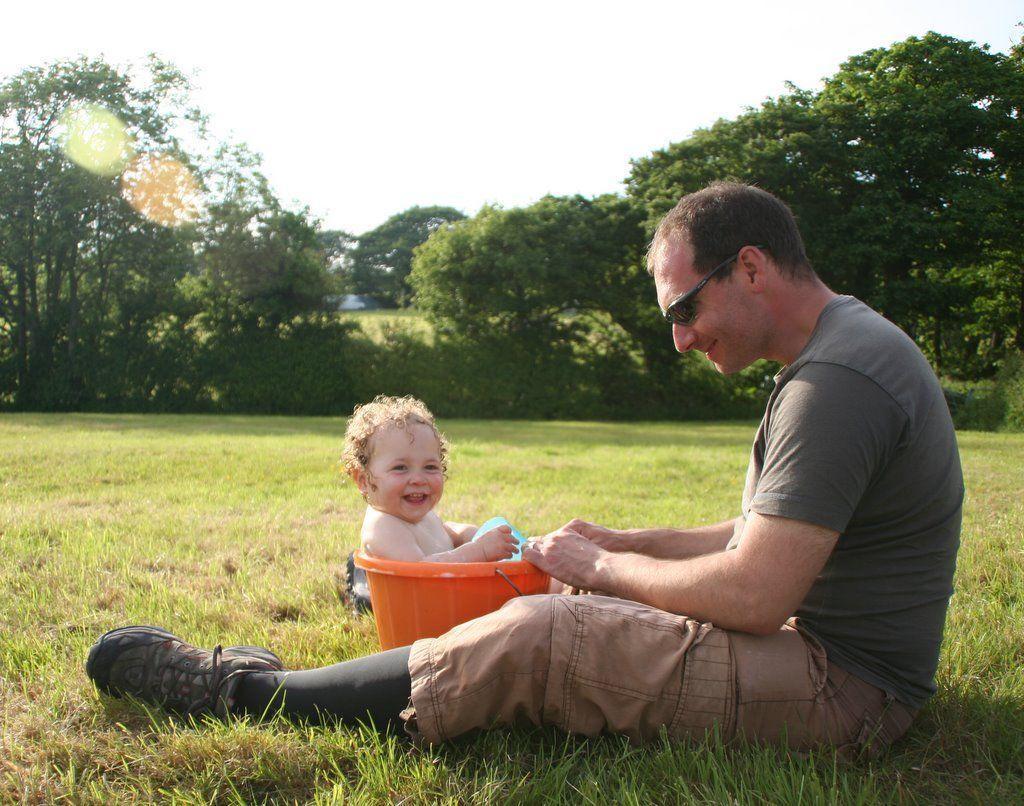Please provide a concise description of this image. In this image there is a person wearing goggles, shoes shirt is sitting on a grassy land before a bucket which is having a kid in it. Background there are few trees and sky 